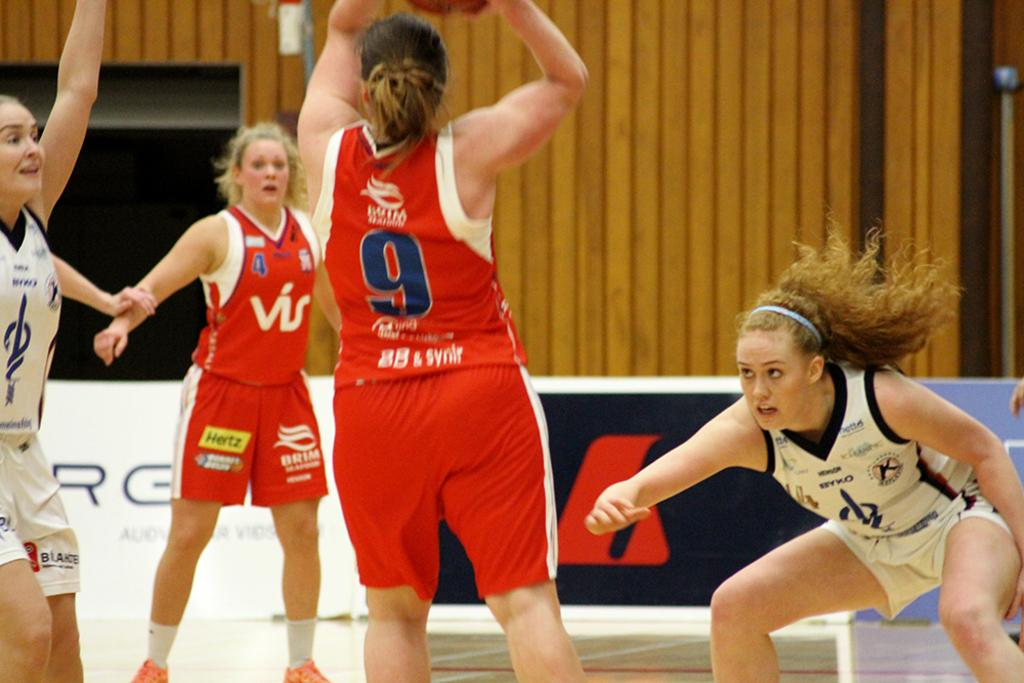Provide a one-sentence caption for the provided image. A girls basketball game is intense, as number 9 goes for the basket. 